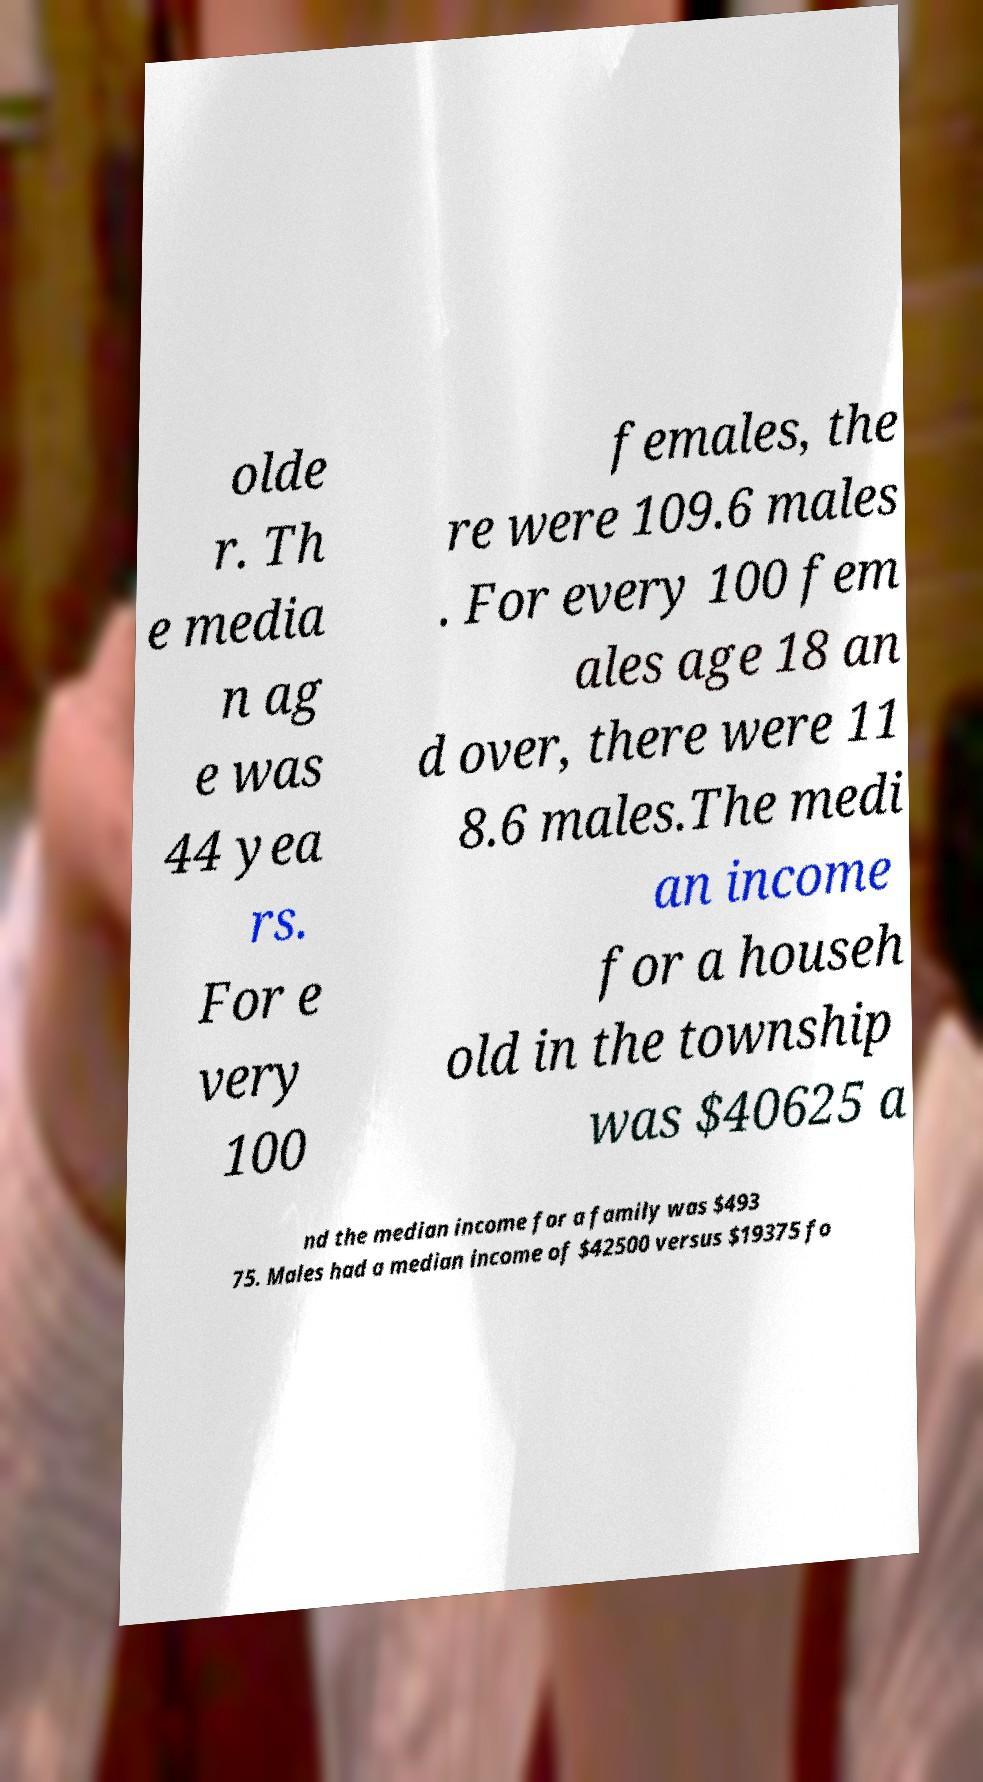Can you accurately transcribe the text from the provided image for me? olde r. Th e media n ag e was 44 yea rs. For e very 100 females, the re were 109.6 males . For every 100 fem ales age 18 an d over, there were 11 8.6 males.The medi an income for a househ old in the township was $40625 a nd the median income for a family was $493 75. Males had a median income of $42500 versus $19375 fo 